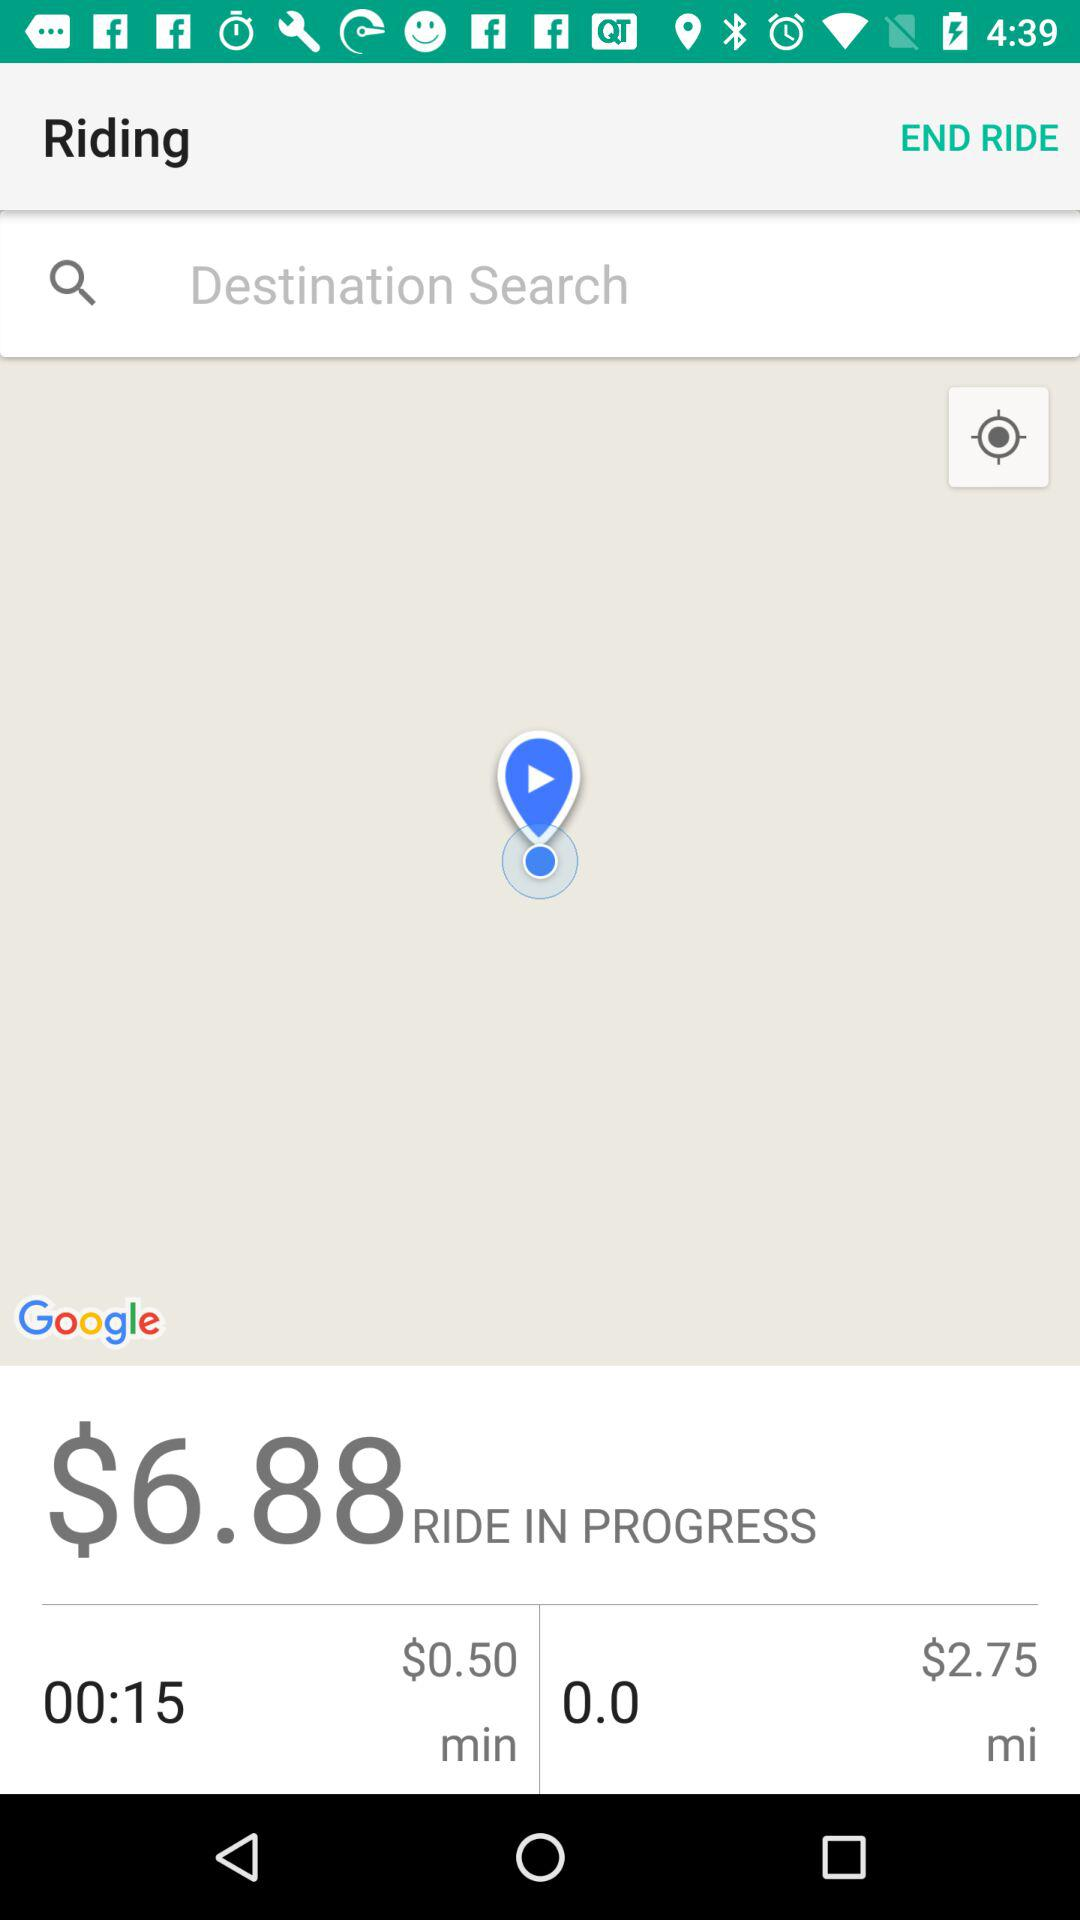What is the given timing? The given timing is 15 seconds. 